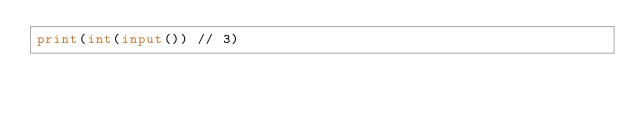Convert code to text. <code><loc_0><loc_0><loc_500><loc_500><_Python_>print(int(input()) // 3)</code> 